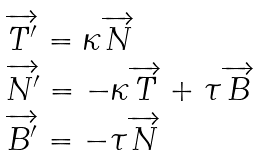<formula> <loc_0><loc_0><loc_500><loc_500>\begin{array} { l } \overrightarrow { T ^ { \prime } } = \kappa \overrightarrow { N } \\ \overrightarrow { N ^ { \prime } } = - \kappa \overrightarrow { T } + \tau \overrightarrow { B } \\ \overrightarrow { B ^ { \prime } } = - \tau \overrightarrow { N } \\ \end{array}</formula> 